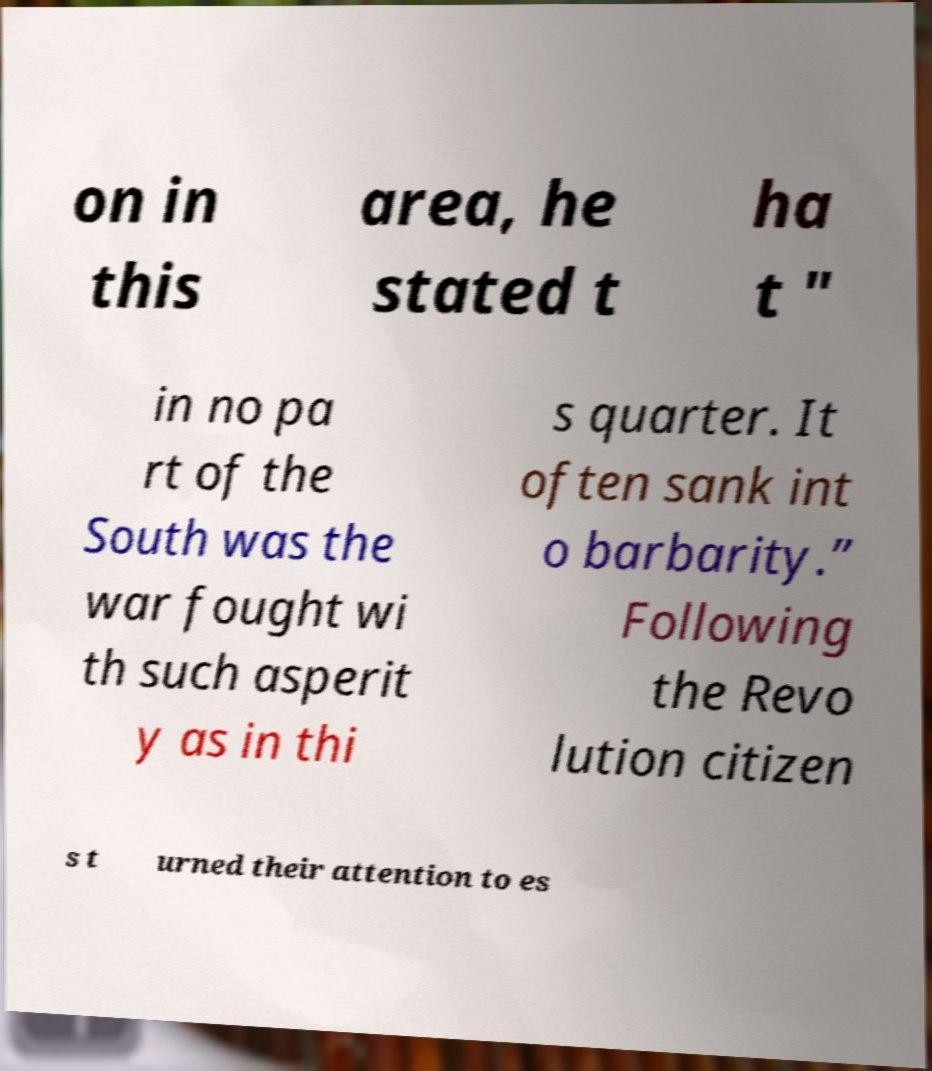Can you read and provide the text displayed in the image?This photo seems to have some interesting text. Can you extract and type it out for me? on in this area, he stated t ha t " in no pa rt of the South was the war fought wi th such asperit y as in thi s quarter. It often sank int o barbarity.” Following the Revo lution citizen s t urned their attention to es 